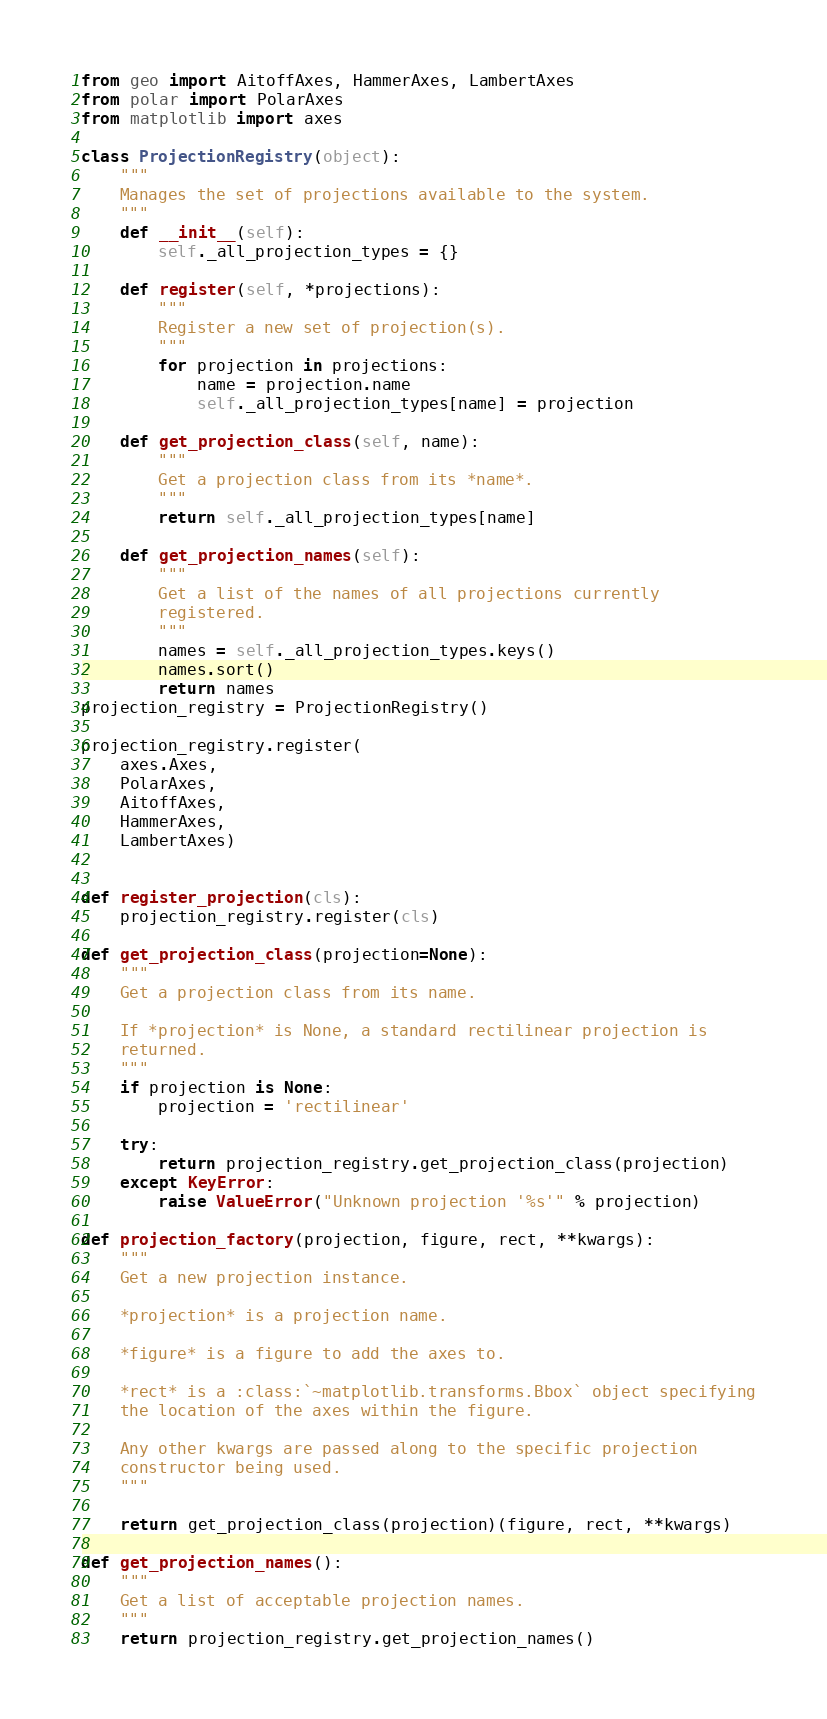Convert code to text. <code><loc_0><loc_0><loc_500><loc_500><_Python_>from geo import AitoffAxes, HammerAxes, LambertAxes
from polar import PolarAxes
from matplotlib import axes

class ProjectionRegistry(object):
    """
    Manages the set of projections available to the system.
    """
    def __init__(self):
        self._all_projection_types = {}

    def register(self, *projections):
        """
        Register a new set of projection(s).
        """
        for projection in projections:
            name = projection.name
            self._all_projection_types[name] = projection

    def get_projection_class(self, name):
        """
        Get a projection class from its *name*.
        """
        return self._all_projection_types[name]

    def get_projection_names(self):
        """
        Get a list of the names of all projections currently
        registered.
        """
        names = self._all_projection_types.keys()
        names.sort()
        return names
projection_registry = ProjectionRegistry()

projection_registry.register(
    axes.Axes,
    PolarAxes,
    AitoffAxes,
    HammerAxes,
    LambertAxes)


def register_projection(cls):
    projection_registry.register(cls)

def get_projection_class(projection=None):
    """
    Get a projection class from its name.

    If *projection* is None, a standard rectilinear projection is
    returned.
    """
    if projection is None:
        projection = 'rectilinear'

    try:
        return projection_registry.get_projection_class(projection)
    except KeyError:
        raise ValueError("Unknown projection '%s'" % projection)

def projection_factory(projection, figure, rect, **kwargs):
    """
    Get a new projection instance.

    *projection* is a projection name.

    *figure* is a figure to add the axes to.

    *rect* is a :class:`~matplotlib.transforms.Bbox` object specifying
    the location of the axes within the figure.

    Any other kwargs are passed along to the specific projection
    constructor being used.
    """

    return get_projection_class(projection)(figure, rect, **kwargs)

def get_projection_names():
    """
    Get a list of acceptable projection names.
    """
    return projection_registry.get_projection_names()
</code> 